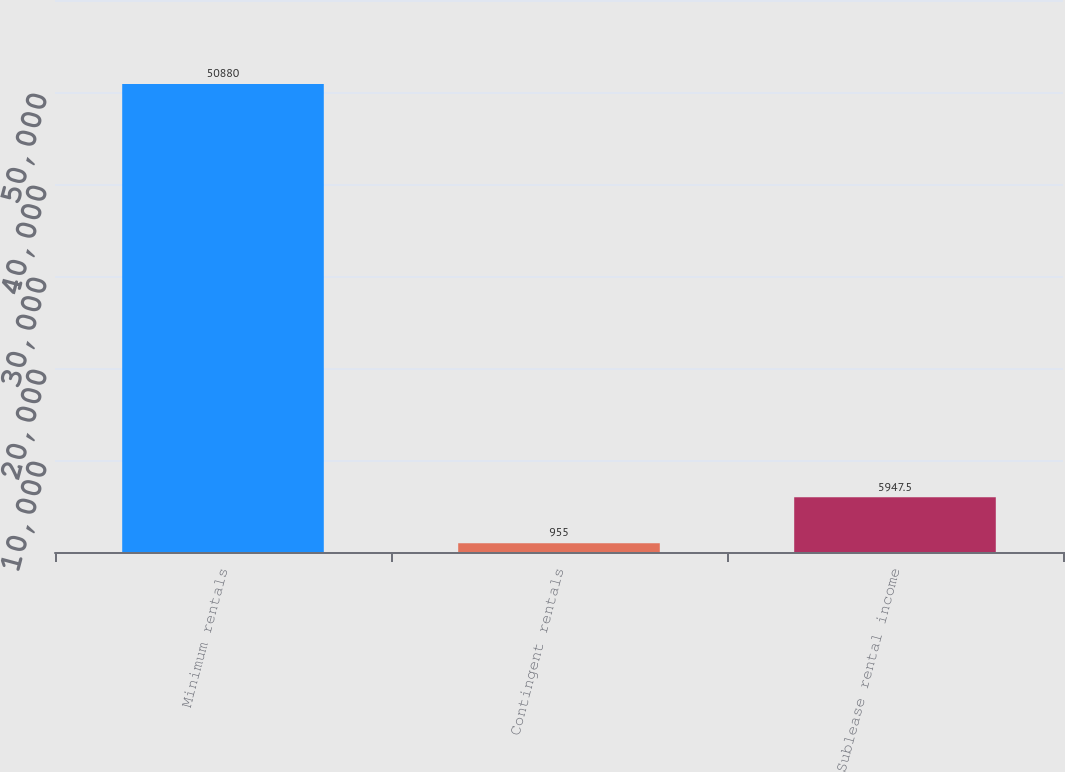Convert chart. <chart><loc_0><loc_0><loc_500><loc_500><bar_chart><fcel>Minimum rentals<fcel>Contingent rentals<fcel>Sublease rental income<nl><fcel>50880<fcel>955<fcel>5947.5<nl></chart> 